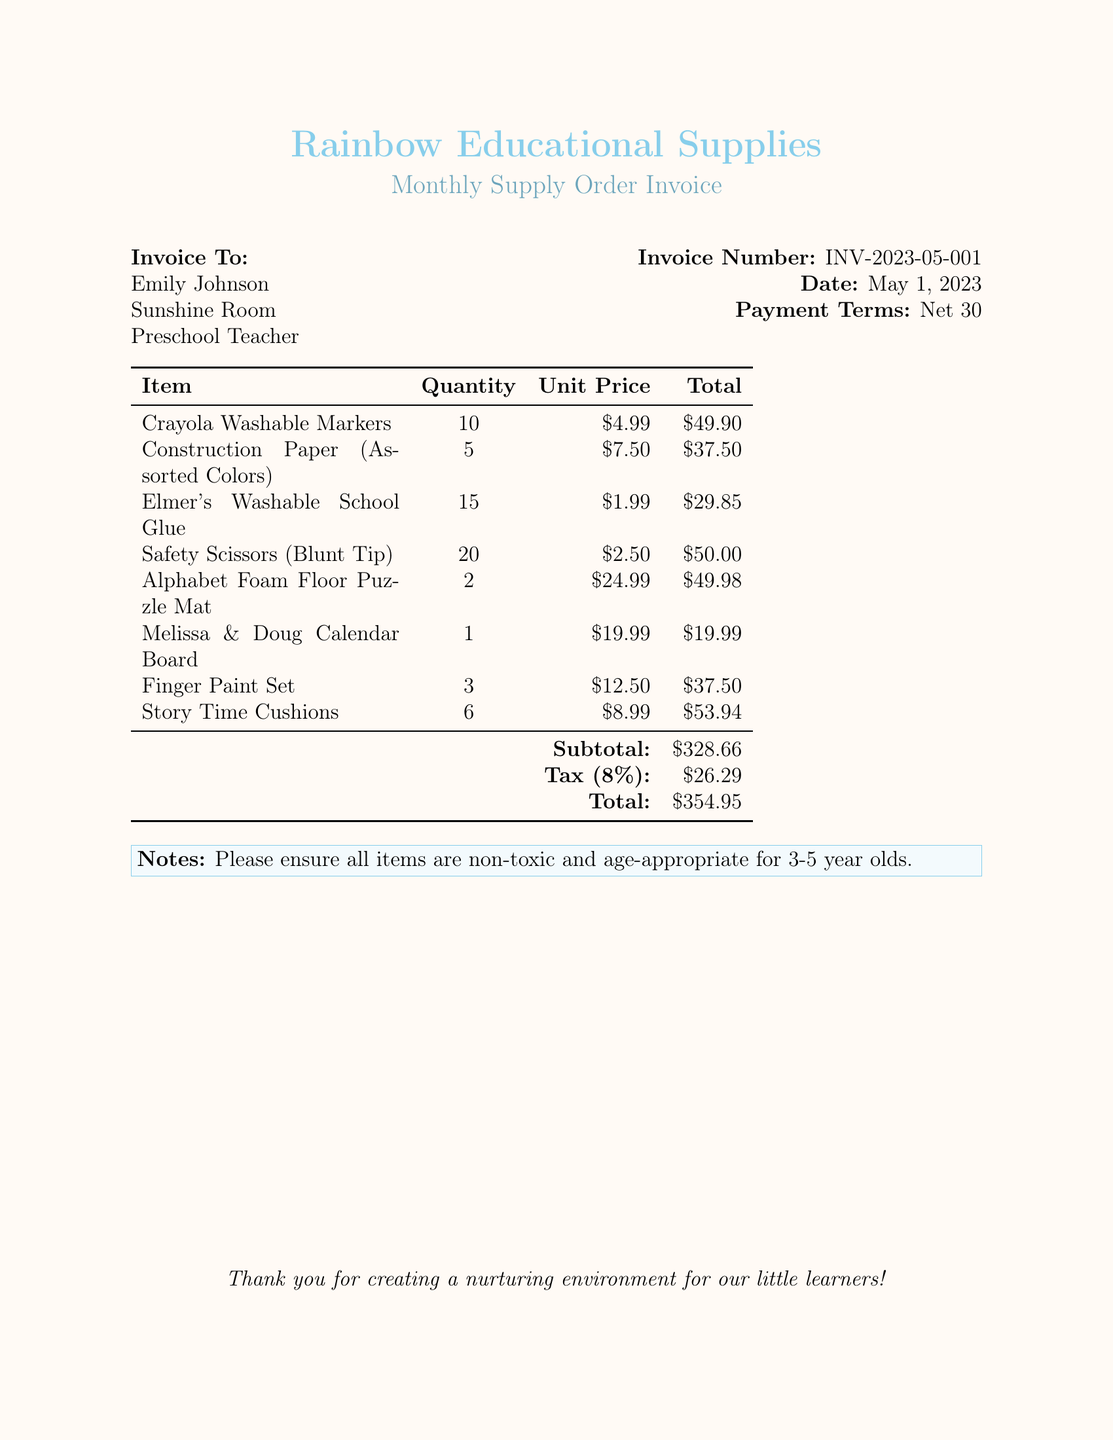What is the invoice number? The invoice number is specified in the document to uniquely identify the invoice.
Answer: INV-2023-05-001 What is the date of the invoice? The date indicates when the invoice was issued, which can be found in the document.
Answer: May 1, 2023 How many Crayola Washable Markers were ordered? The quantity of Crayola Washable Markers is clearly listed in the itemized list of the invoice.
Answer: 10 What is the total amount for the invoice? The total amount is the final sum presented at the bottom of the invoice, including tax.
Answer: $354.95 What is the subtotal of the items before tax? The subtotal represents the sum of all item totals before tax is applied, which is indicated in the document.
Answer: $328.66 What percentage tax is applied to the subtotal? The tax percentage is provided in the document and calculated based on the subtotal.
Answer: 8% How many Story Time Cushions were ordered? The quantity of Story Time Cushions can be found in the itemized list of the invoice.
Answer: 6 What is the payment term for this invoice? Payment terms clarify the duration for payment, mentioned in the invoice information.
Answer: Net 30 What specific note is included regarding item selection? The note provides guidance on selecting appropriate items for the target age group, found in the document.
Answer: non-toxic and age-appropriate for 3-5 year olds 